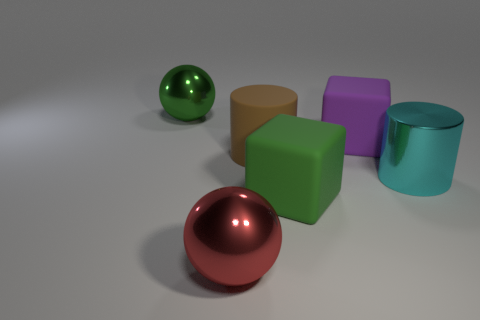Do the large brown thing and the large cyan object have the same material?
Your answer should be very brief. No. There is a purple matte object behind the large green matte thing; is it the same shape as the green rubber object that is on the left side of the purple thing?
Offer a terse response. Yes. What number of objects are green matte cubes or big green things?
Offer a terse response. 2. What is the material of the big green block in front of the large cylinder that is right of the big green matte block?
Keep it short and to the point. Rubber. What is the color of the other matte block that is the same size as the purple matte cube?
Keep it short and to the point. Green. There is a big green object behind the cyan metal cylinder that is right of the metal ball behind the large red metal object; what is it made of?
Offer a terse response. Metal. What number of things are large blocks that are on the right side of the green cube or big balls to the left of the red sphere?
Ensure brevity in your answer.  2. There is a green thing to the right of the large green object that is left of the big brown object; what is its shape?
Your answer should be compact. Cube. Are there any big brown things made of the same material as the red sphere?
Offer a very short reply. No. There is another large object that is the same shape as the red thing; what is its color?
Give a very brief answer. Green. 